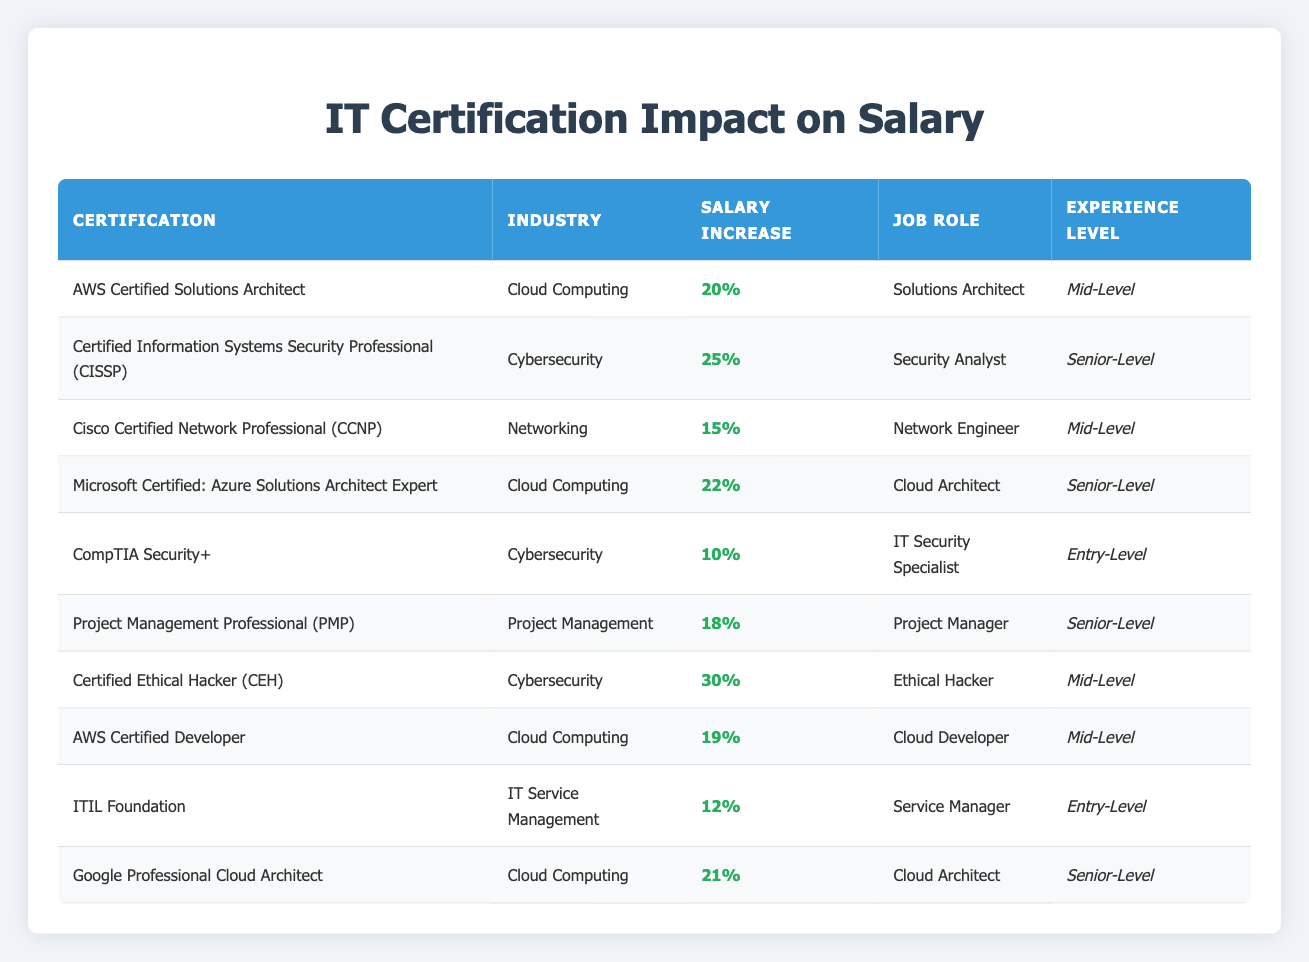What is the average salary increase for certifications in Cybersecurity? There are three Cybersecurity certifications listed: CISSP (25%), CompTIA Security+ (10%), and Certified Ethical Hacker (CEH) (30%). To calculate the average, sum the percentages: 25 + 10 + 30 = 65. Then divide by the number of certifications: 65/3 = 21.67%.
Answer: 21.67% Which certification has the highest average salary increase? The Certified Ethical Hacker (CEH) has the highest average salary increase of 30%, compared to other certifications listed.
Answer: 30% Is there any certification in Cybersecurity for Entry-Level positions? Yes, the CompTIA Security+ certification is the only one listed for Entry-Level positions in the Cybersecurity category.
Answer: Yes What is the total percentage increase for all certifications in Cloud Computing? The certifications for Cloud Computing listed are the AWS Certified Solutions Architect (20%), Microsoft Certified: Azure Solutions Architect Expert (22%), AWS Certified Developer (19%), and Google Professional Cloud Architect (21%). The total salary increase is calculated by adding them: 20 + 22 + 19 + 21 = 82%.
Answer: 82% Are there any certifications that provide less than a 15% average salary increase? Yes, the CompTIA Security+ (10%) and Cisco Certified Network Professional (CCNP) (15%) provide less than or equal to a 15% average salary increase.
Answer: Yes Which job role associated with the certification has the highest required experience level? The certification with the highest required experience level (Senior-Level) is associated with the following job roles: Security Analyst (CISSP), Cloud Architect (Microsoft Certified: Azure Solutions Architect Expert), and Cloud Architect (Google Professional Cloud Architect). Any of these can be considered the answer to the job role with the highest experience level.
Answer: Multiple roles: Security Analyst, Cloud Architect What is the difference in average salary increase between the highest and lowest certifications? The highest average salary increase is from the Certified Ethical Hacker (CEH) at 30%, and the lowest is from the CompTIA Security+ at 10%. The difference is calculated by subtracting the lowest from the highest: 30 - 10 = 20%.
Answer: 20% How many certifications listed are aimed at Mid-Level experience? There are four certifications for Mid-Level experience: AWS Certified Solutions Architect, Cisco Certified Network Professional (CCNP), Certified Ethical Hacker (CEH), and AWS Certified Developer.
Answer: 4 